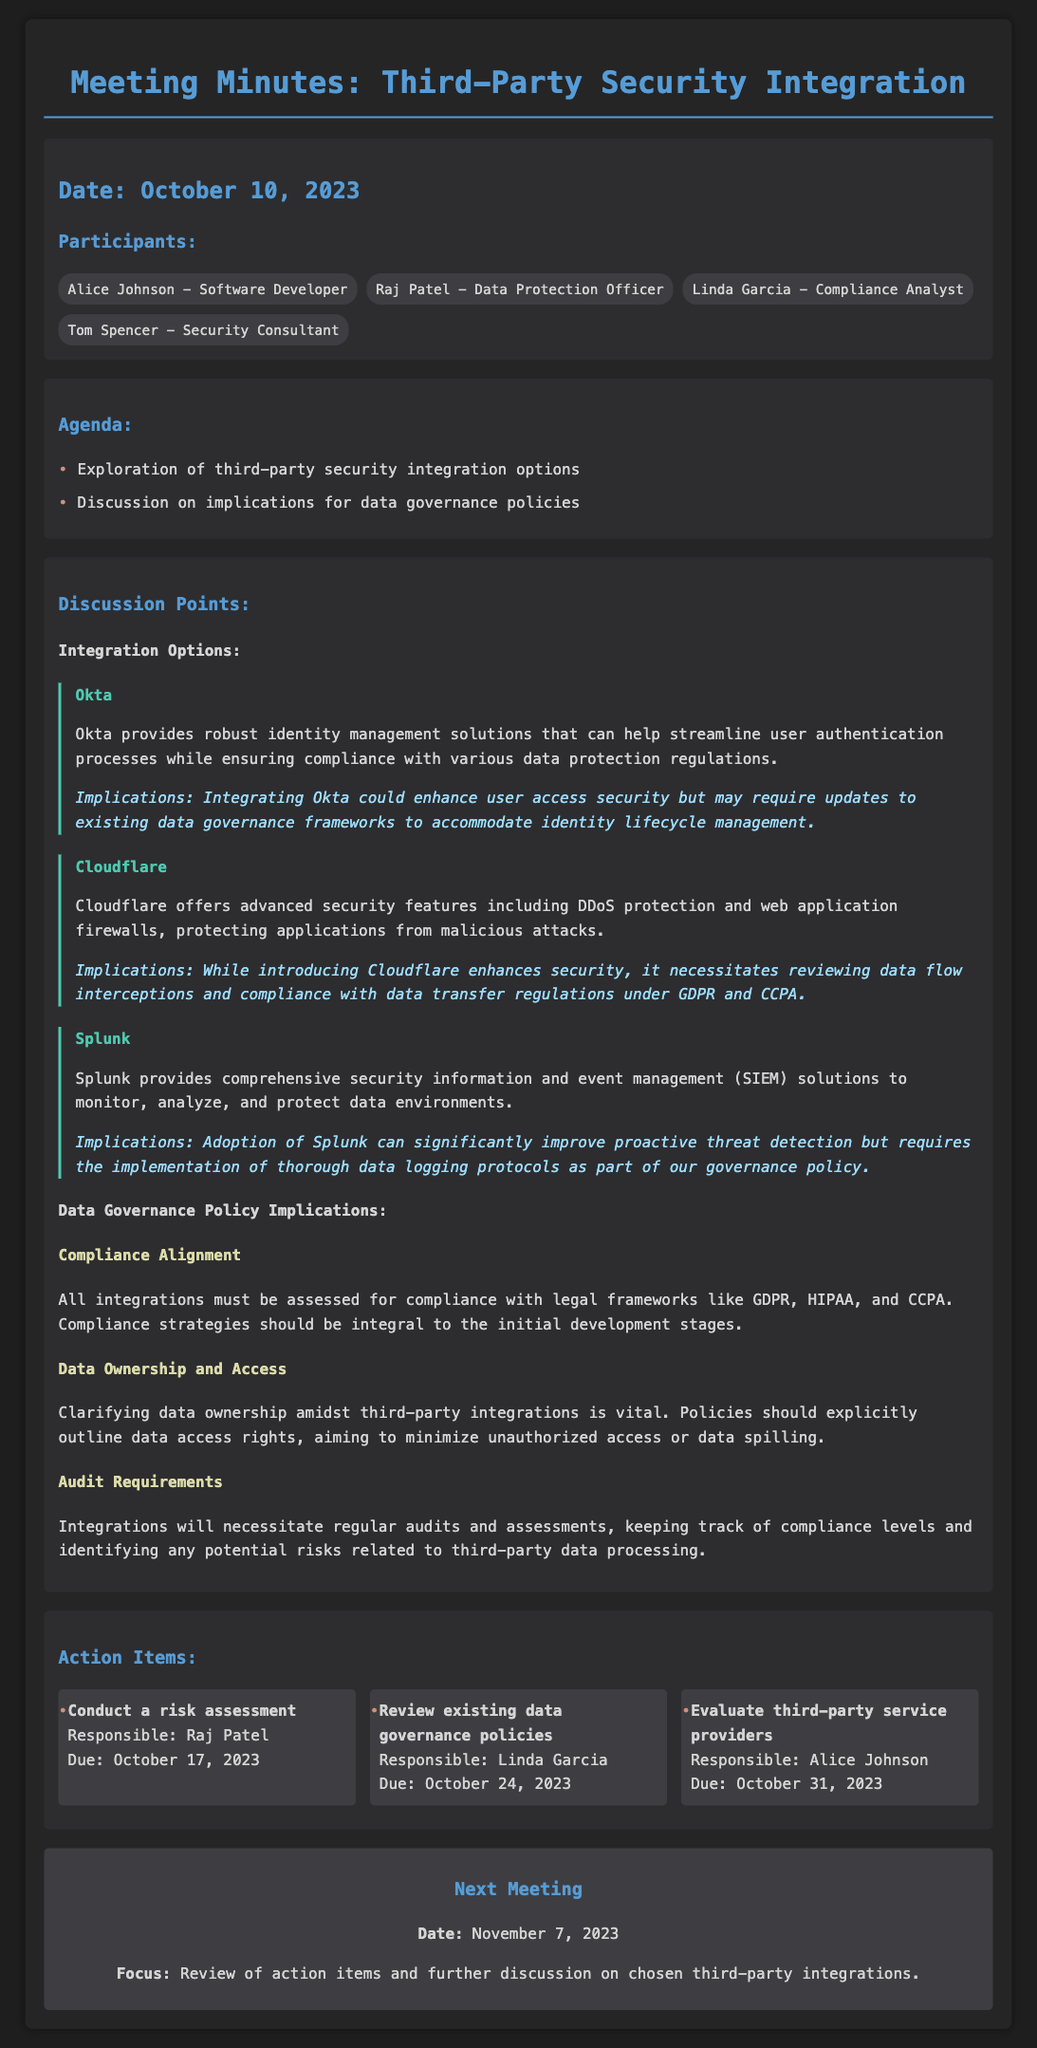what is the date of the meeting? The date of the meeting is provided in the document as October 10, 2023.
Answer: October 10, 2023 who is the Data Protection Officer? The name of the Data Protection Officer is mentioned among the participants.
Answer: Raj Patel how many integration options were discussed? The document lists three integration options under the discussion points.
Answer: Three what is the due date for the risk assessment action item? The due date for the risk assessment is specified in the action items section.
Answer: October 17, 2023 which tool is suggested for identity management? The name of the tool that provides identity management solutions is mentioned in the integration options.
Answer: Okta what is one implication of integrating Cloudflare? The implications of integrating Cloudflare are summarized in its discussion point.
Answer: Review data flow interceptions who is responsible for reviewing existing data governance policies? The action items section specifies who is responsible for this task.
Answer: Linda Garcia what will be the focus of the next meeting? The focus of the next meeting is outlined in the section about the next meeting.
Answer: Review of action items and further discussion on chosen third-party integrations 